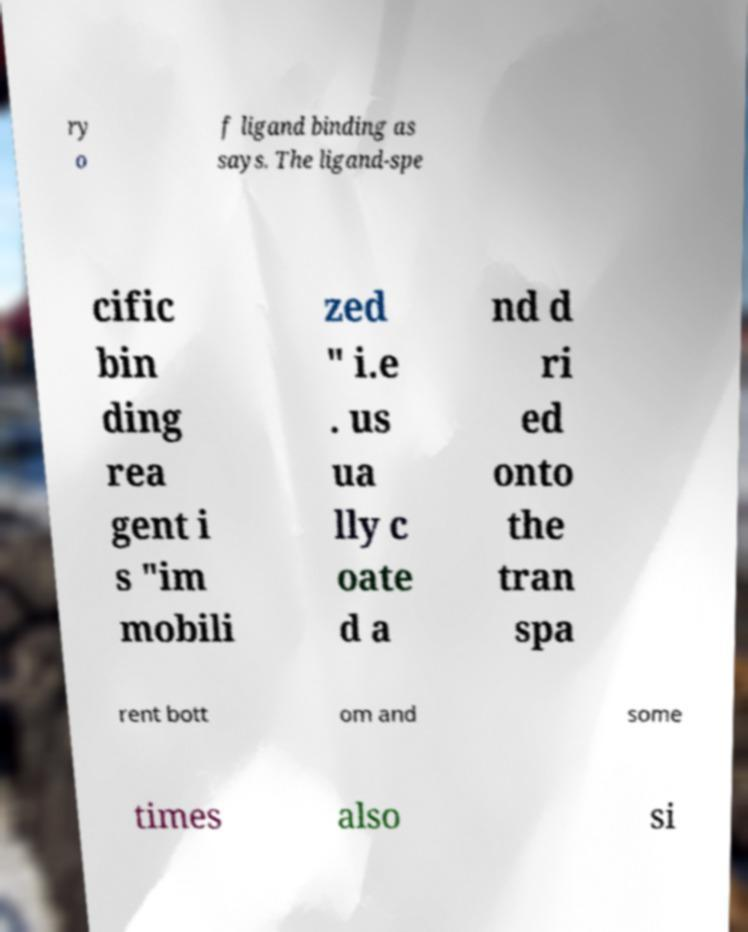Could you extract and type out the text from this image? ry o f ligand binding as says. The ligand-spe cific bin ding rea gent i s "im mobili zed " i.e . us ua lly c oate d a nd d ri ed onto the tran spa rent bott om and some times also si 